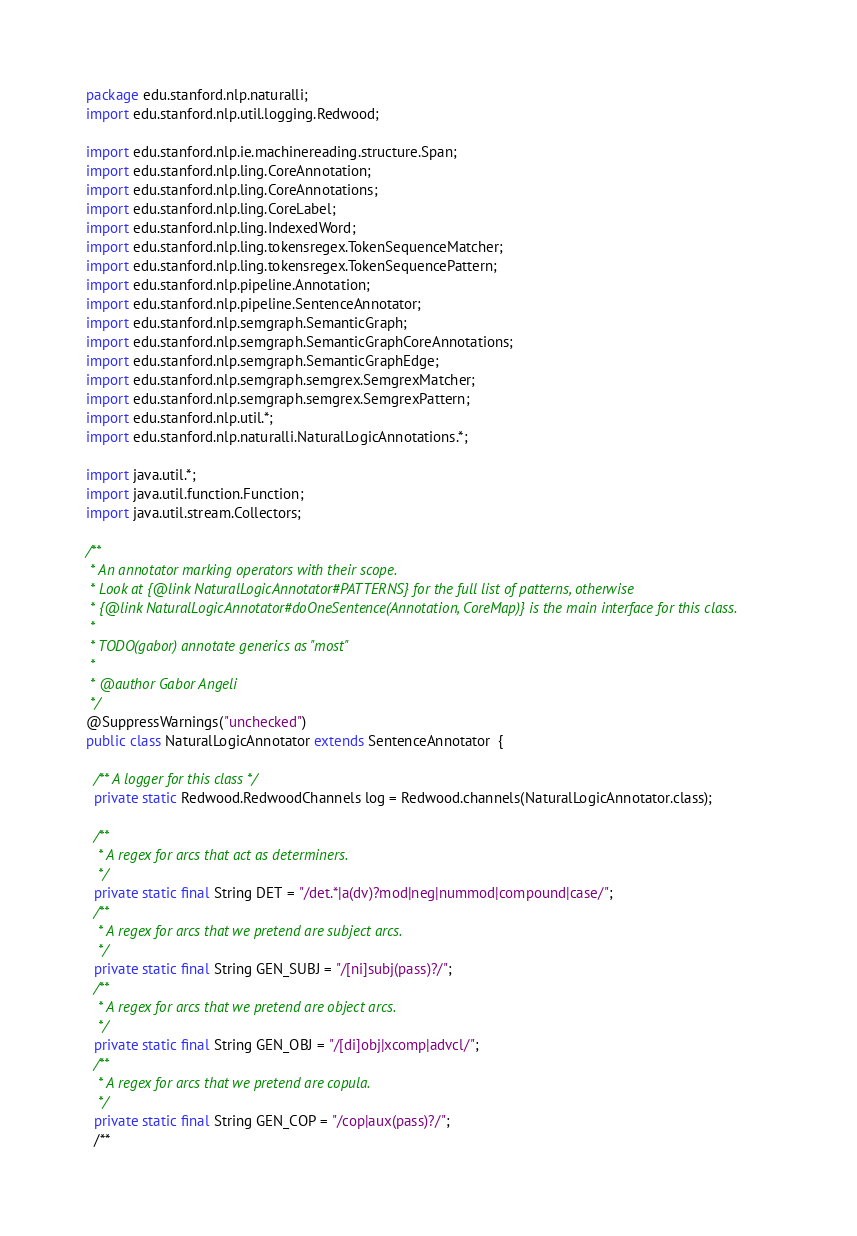<code> <loc_0><loc_0><loc_500><loc_500><_Java_>package edu.stanford.nlp.naturalli;
import edu.stanford.nlp.util.logging.Redwood;

import edu.stanford.nlp.ie.machinereading.structure.Span;
import edu.stanford.nlp.ling.CoreAnnotation;
import edu.stanford.nlp.ling.CoreAnnotations;
import edu.stanford.nlp.ling.CoreLabel;
import edu.stanford.nlp.ling.IndexedWord;
import edu.stanford.nlp.ling.tokensregex.TokenSequenceMatcher;
import edu.stanford.nlp.ling.tokensregex.TokenSequencePattern;
import edu.stanford.nlp.pipeline.Annotation;
import edu.stanford.nlp.pipeline.SentenceAnnotator;
import edu.stanford.nlp.semgraph.SemanticGraph;
import edu.stanford.nlp.semgraph.SemanticGraphCoreAnnotations;
import edu.stanford.nlp.semgraph.SemanticGraphEdge;
import edu.stanford.nlp.semgraph.semgrex.SemgrexMatcher;
import edu.stanford.nlp.semgraph.semgrex.SemgrexPattern;
import edu.stanford.nlp.util.*;
import edu.stanford.nlp.naturalli.NaturalLogicAnnotations.*;

import java.util.*;
import java.util.function.Function;
import java.util.stream.Collectors;

/**
 * An annotator marking operators with their scope.
 * Look at {@link NaturalLogicAnnotator#PATTERNS} for the full list of patterns, otherwise
 * {@link NaturalLogicAnnotator#doOneSentence(Annotation, CoreMap)} is the main interface for this class.
 *
 * TODO(gabor) annotate generics as "most"
 *
 * @author Gabor Angeli
 */
@SuppressWarnings("unchecked")
public class NaturalLogicAnnotator extends SentenceAnnotator  {

  /** A logger for this class */
  private static Redwood.RedwoodChannels log = Redwood.channels(NaturalLogicAnnotator.class);

  /**
   * A regex for arcs that act as determiners.
   */
  private static final String DET = "/det.*|a(dv)?mod|neg|nummod|compound|case/";
  /**
   * A regex for arcs that we pretend are subject arcs.
   */
  private static final String GEN_SUBJ = "/[ni]subj(pass)?/";
  /**
   * A regex for arcs that we pretend are object arcs.
   */
  private static final String GEN_OBJ = "/[di]obj|xcomp|advcl/";
  /**
   * A regex for arcs that we pretend are copula.
   */
  private static final String GEN_COP = "/cop|aux(pass)?/";
  /**</code> 